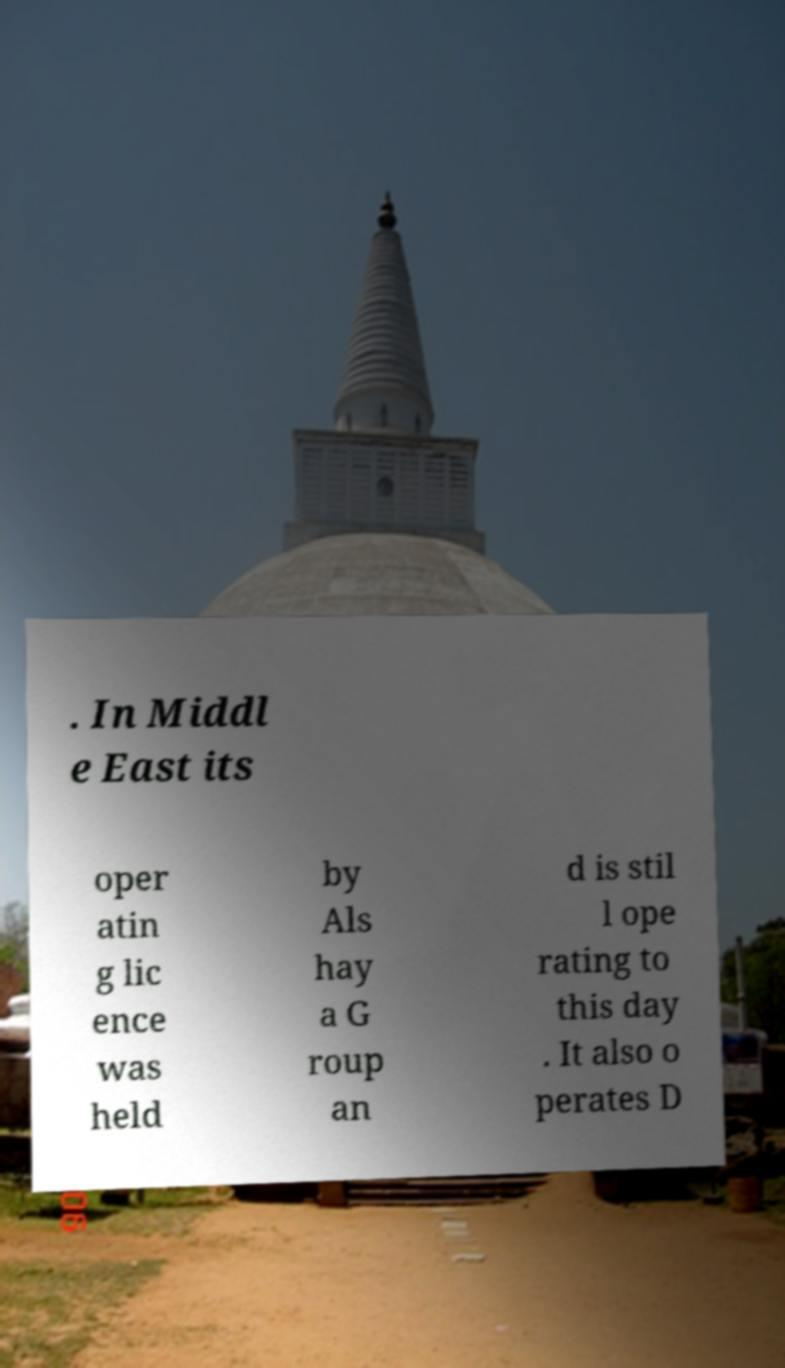Could you extract and type out the text from this image? . In Middl e East its oper atin g lic ence was held by Als hay a G roup an d is stil l ope rating to this day . It also o perates D 